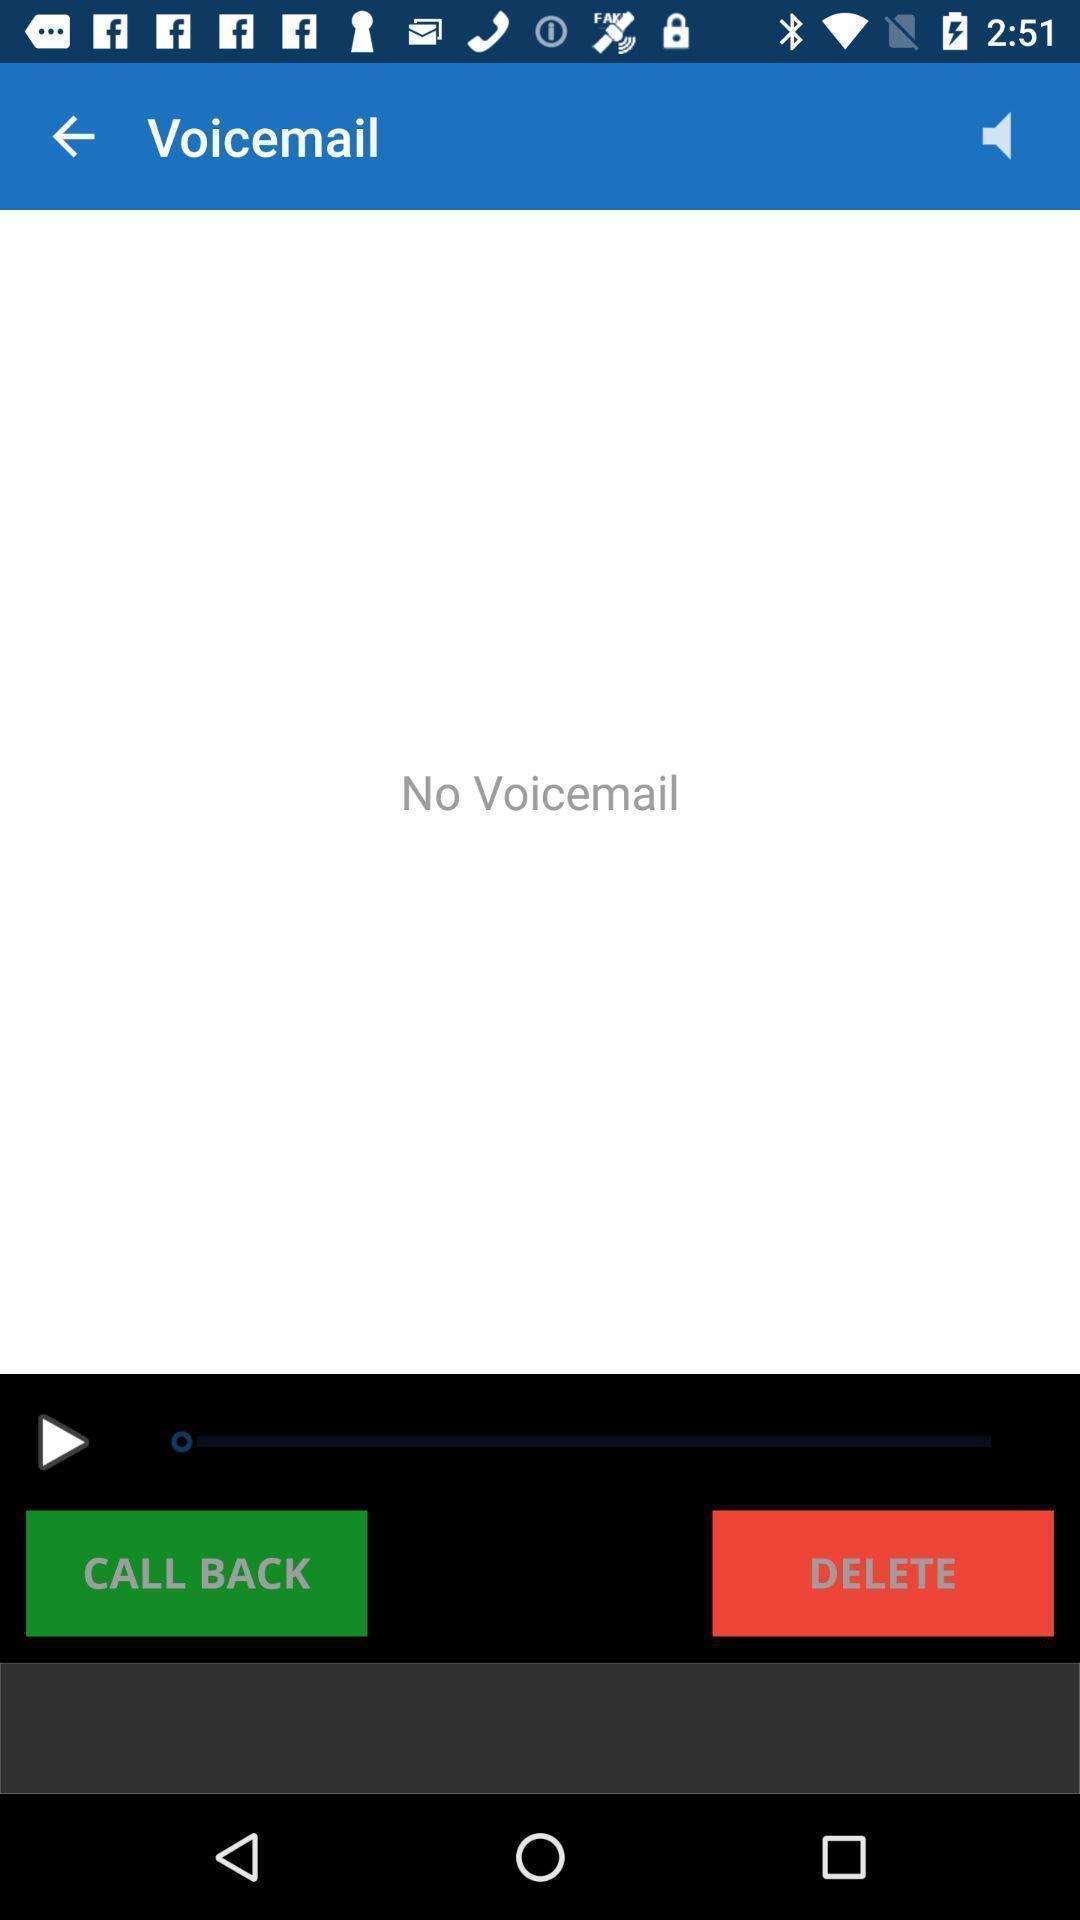Describe this image in words. Screen shows no voice mail on a device. 